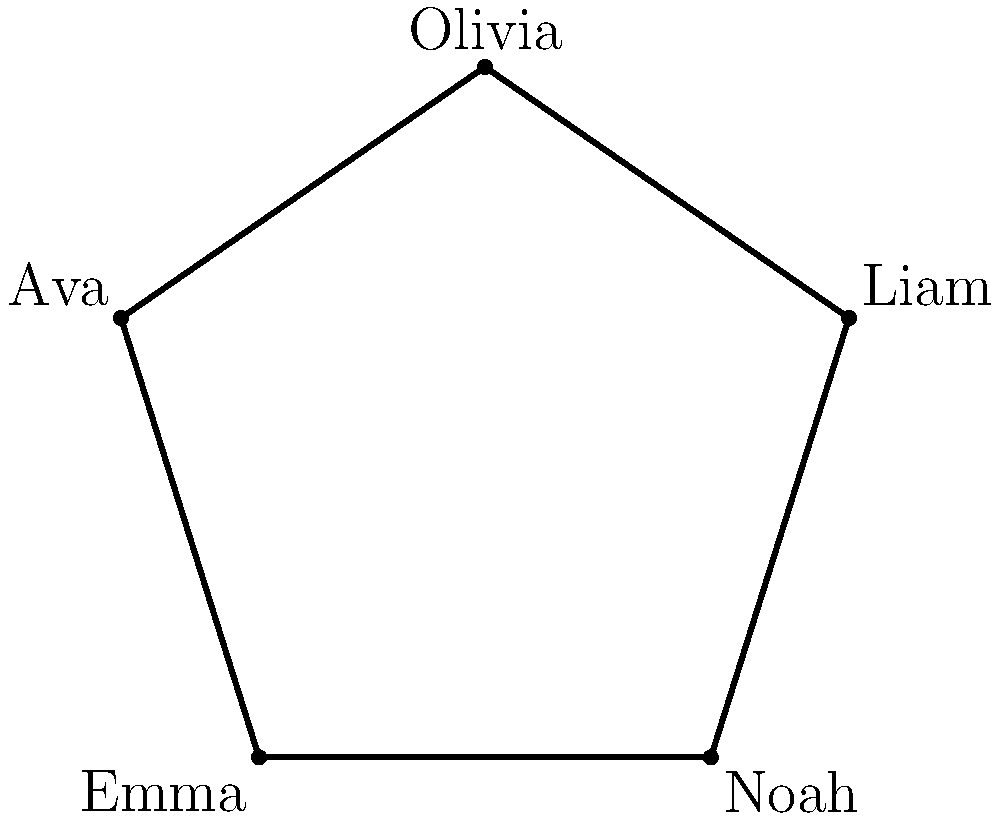A star-shaped figure represents the top 5 baby names of 2021. Each point of the star corresponds to a name, and the distance between adjacent points is proportional to the popularity gap between the names. If the total perimeter of the star is 50 units, and the segment representing the popularity gap between "Liam" and "Noah" is 12 units, what is the average length of the remaining segments? Let's approach this step-by-step:

1) The star has 5 segments in total, corresponding to the gaps between:
   Olivia-Liam, Liam-Noah, Noah-Emma, Emma-Ava, and Ava-Olivia.

2) We're given that the total perimeter is 50 units, and one segment (Liam-Noah) is 12 units.

3) Let's denote the sum of the other 4 segments as $x$. Then:

   $x + 12 = 50$

4) Solving for $x$:
   
   $x = 50 - 12 = 38$

5) Now, we need to find the average of these 4 segments. The average is calculated by dividing the sum by the number of segments:

   Average = $\frac{38}{4} = 9.5$

Therefore, the average length of the remaining segments is 9.5 units.
Answer: 9.5 units 